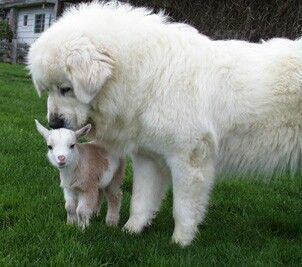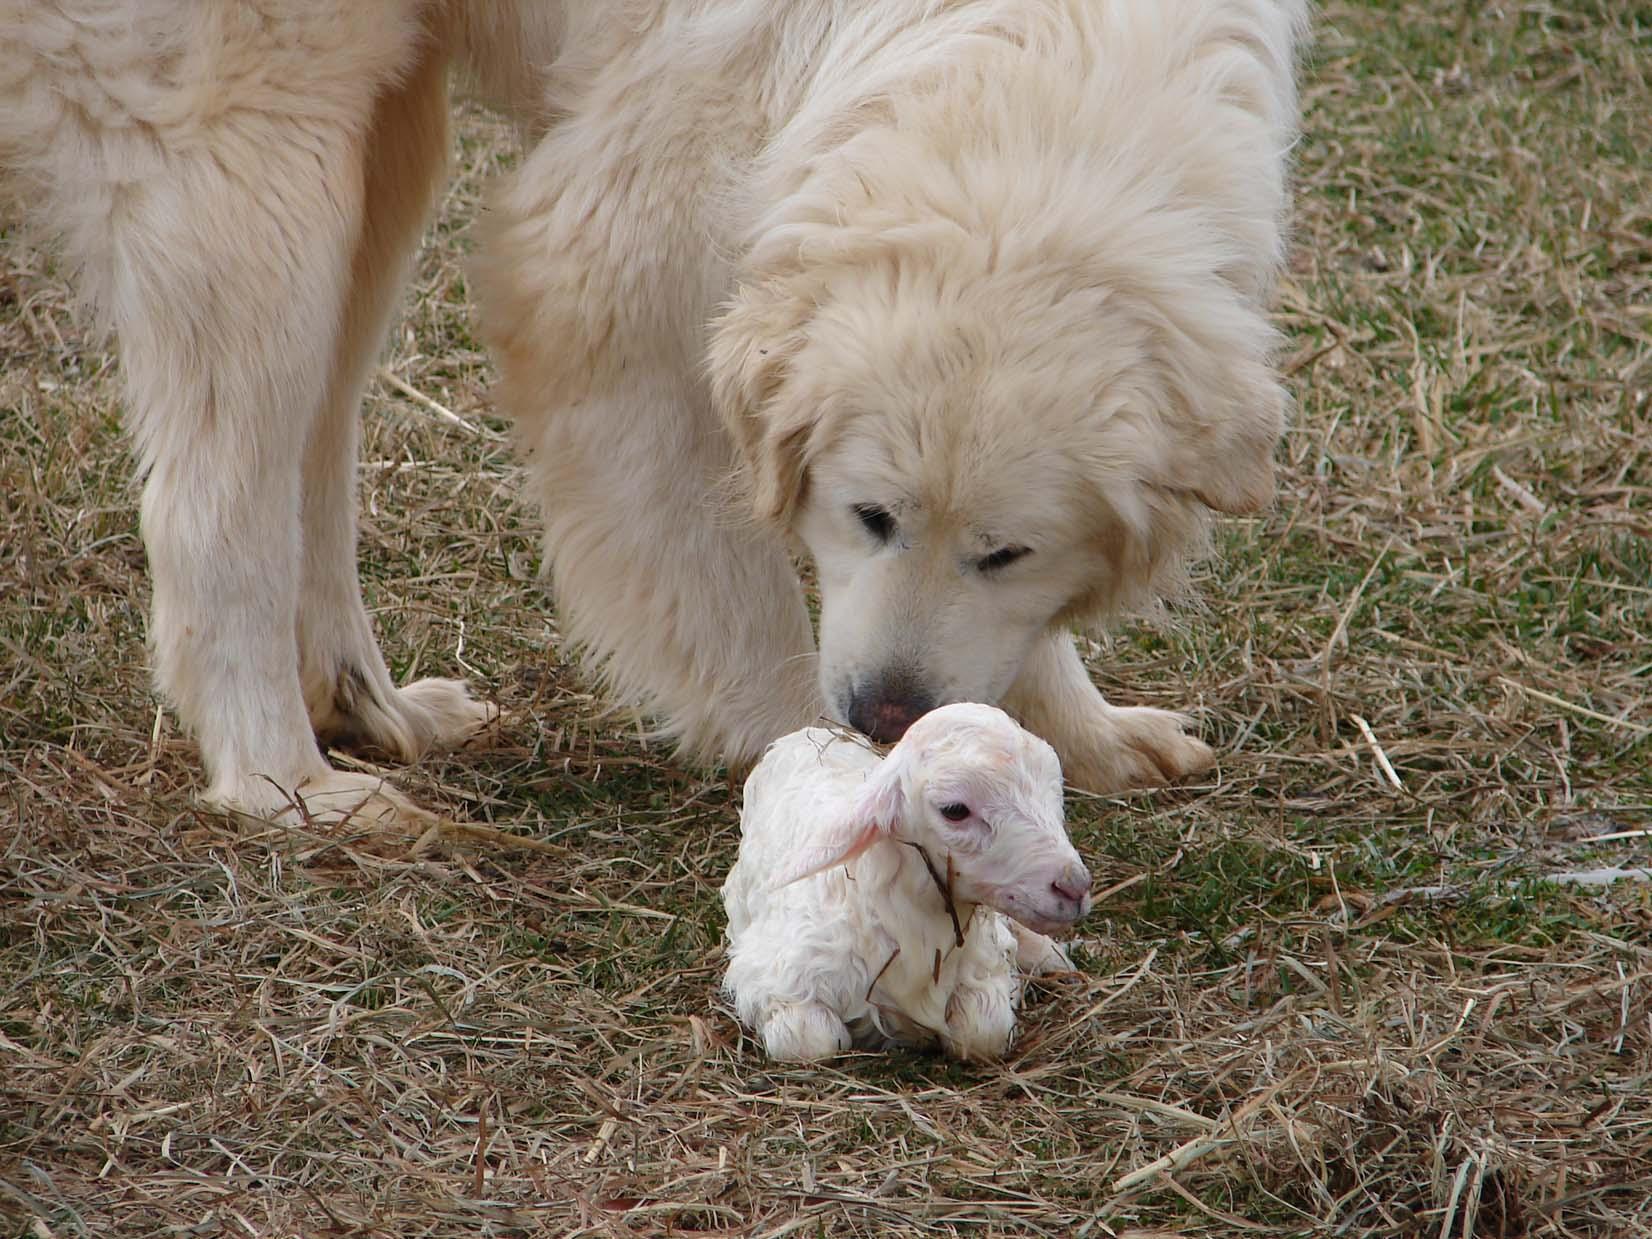The first image is the image on the left, the second image is the image on the right. For the images shown, is this caption "A dog is right next to a sheep in at least one of the images." true? Answer yes or no. Yes. The first image is the image on the left, the second image is the image on the right. For the images shown, is this caption "Both images have a fluffy dog with one or more sheep." true? Answer yes or no. Yes. 